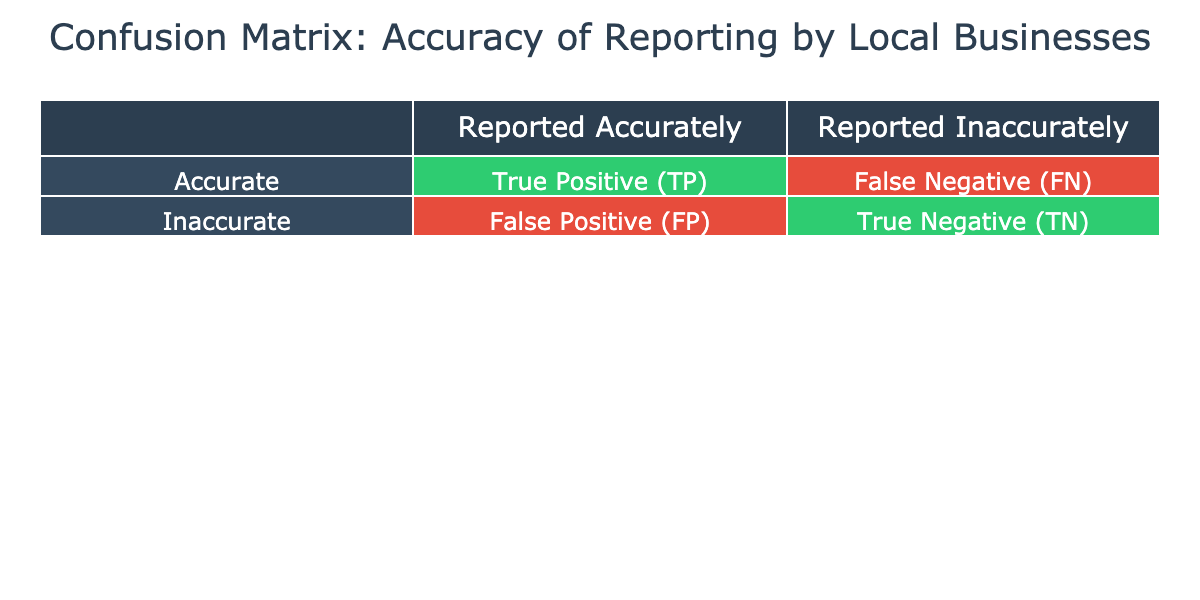What is the total number of local businesses that reported their labor practices accurately? To find the total number of businesses that reported accurately, add the True Positive (TP) values from each business type: 50 (Local Grocery Store) + 75 (Tech Startup) + 30 (Construction Company) + 60 (Manufacturing Plant) + 40 (Restaurant Chain) + 55 (Local Retail Shop) + 20 (Freelance Services) + 70 (Healthcare Provider) + 25 (Transportation Company) + 80 (Educational Institution) = 50 + 75 + 30 + 60 + 40 + 55 + 20 + 70 + 25 + 80 =  455
Answer: 455 What is the number of businesses that reported inaccurately across all categories? To find the total number of businesses that reported inaccurately, sum all the False Negative (FN) and True Negative (TN) values: 5 (Local Grocery Store) + 10 (Tech Startup) + 20 (Construction Company) + 15 (Manufacturing Plant) + 8 (Restaurant Chain) + 12 (Local Retail Shop) + 2 (Freelance Services) + 5 (Healthcare Provider) + 10 (Transportation Company) + 3 (Educational Institution) = 5 + 10 + 20 + 15 + 8 + 12 + 2 + 5 + 10 + 3 =  85
Answer: 85 Is the Transportation Company reporting accurately according to the data? The Transportation Company has a True Positive (TP) count of 25, meaning it reported accurately, while it has a False Negative (FN) count of 10. This indicates that it did meet the criteria for reporting accuracy set in the matrix.
Answer: Yes Which business has the highest number of accurate reports? By examining the True Positive (TP) column, the Educational Institution has the highest count at 80, compared to all other businesses. This shows that it reported the highest number of accurate practices.
Answer: Educational Institution What is the average number of accurate reports among the local businesses? To find the average, first add all the True Positive (TP) values, which total 455. Then divide this sum by the number of businesses, which is 10. So, 455 / 10 = 45.5
Answer: 45.5 How many more businesses reported inaccurately than accurately? The total number of businesses that reported inaccurately is 85. The total number that reported accurately is 455. The difference is found by subtracting the accurately reported numbers from the inaccurately reported numbers: 85 - 455 = -370. Since this is negative, it indicates that many more businesses reported accurately than inaccurately.
Answer: 370 more accurately reported What percentage of the Manufacturing Plant's reports were accurate? The Manufacturing Plant reported 60 accurately and 15 inaccurately. To find the percentage of accurate reports, use the formula: (TP / total reports) * 100 = (60 / (60 + 15)) * 100 = (60 / 75) * 100 = 80%. This shows that 80% of the reports were accurate.
Answer: 80% Are there any businesses that reported accurately with fewer than 30 inaccurate reports? For this question, only the Construction Company has 20 inaccurate reports and reports accurately with 30. Since it's equal to 30, there are no businesses that reported accurately with fewer than 30 inaccurate reports.
Answer: No 